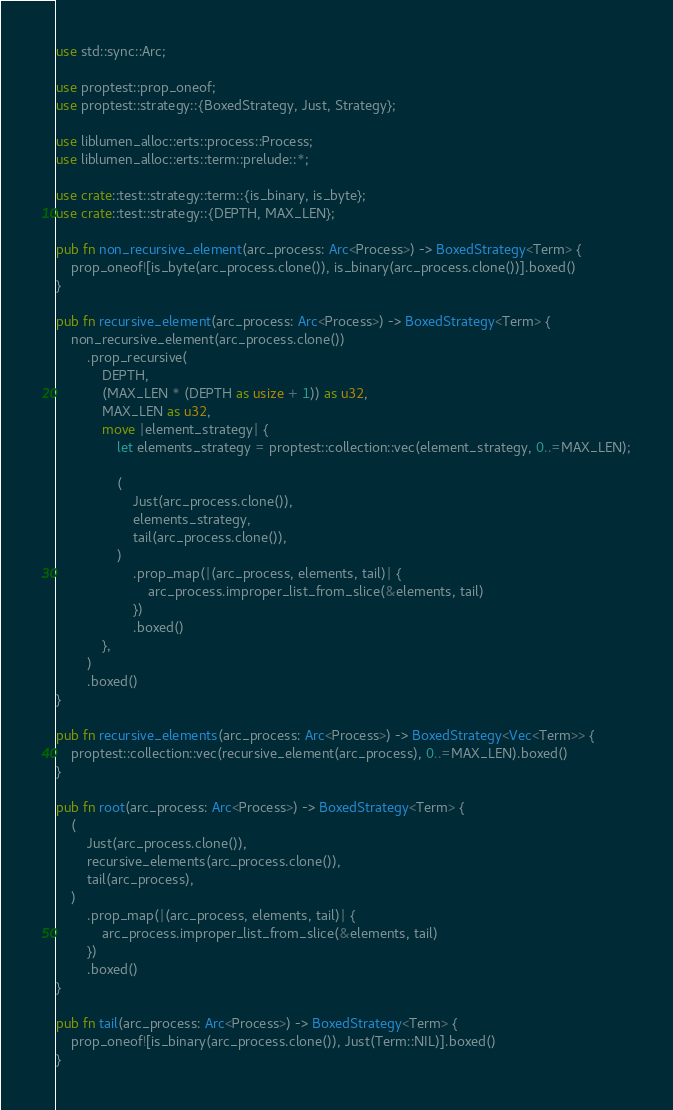<code> <loc_0><loc_0><loc_500><loc_500><_Rust_>use std::sync::Arc;

use proptest::prop_oneof;
use proptest::strategy::{BoxedStrategy, Just, Strategy};

use liblumen_alloc::erts::process::Process;
use liblumen_alloc::erts::term::prelude::*;

use crate::test::strategy::term::{is_binary, is_byte};
use crate::test::strategy::{DEPTH, MAX_LEN};

pub fn non_recursive_element(arc_process: Arc<Process>) -> BoxedStrategy<Term> {
    prop_oneof![is_byte(arc_process.clone()), is_binary(arc_process.clone())].boxed()
}

pub fn recursive_element(arc_process: Arc<Process>) -> BoxedStrategy<Term> {
    non_recursive_element(arc_process.clone())
        .prop_recursive(
            DEPTH,
            (MAX_LEN * (DEPTH as usize + 1)) as u32,
            MAX_LEN as u32,
            move |element_strategy| {
                let elements_strategy = proptest::collection::vec(element_strategy, 0..=MAX_LEN);

                (
                    Just(arc_process.clone()),
                    elements_strategy,
                    tail(arc_process.clone()),
                )
                    .prop_map(|(arc_process, elements, tail)| {
                        arc_process.improper_list_from_slice(&elements, tail)
                    })
                    .boxed()
            },
        )
        .boxed()
}

pub fn recursive_elements(arc_process: Arc<Process>) -> BoxedStrategy<Vec<Term>> {
    proptest::collection::vec(recursive_element(arc_process), 0..=MAX_LEN).boxed()
}

pub fn root(arc_process: Arc<Process>) -> BoxedStrategy<Term> {
    (
        Just(arc_process.clone()),
        recursive_elements(arc_process.clone()),
        tail(arc_process),
    )
        .prop_map(|(arc_process, elements, tail)| {
            arc_process.improper_list_from_slice(&elements, tail)
        })
        .boxed()
}

pub fn tail(arc_process: Arc<Process>) -> BoxedStrategy<Term> {
    prop_oneof![is_binary(arc_process.clone()), Just(Term::NIL)].boxed()
}
</code> 